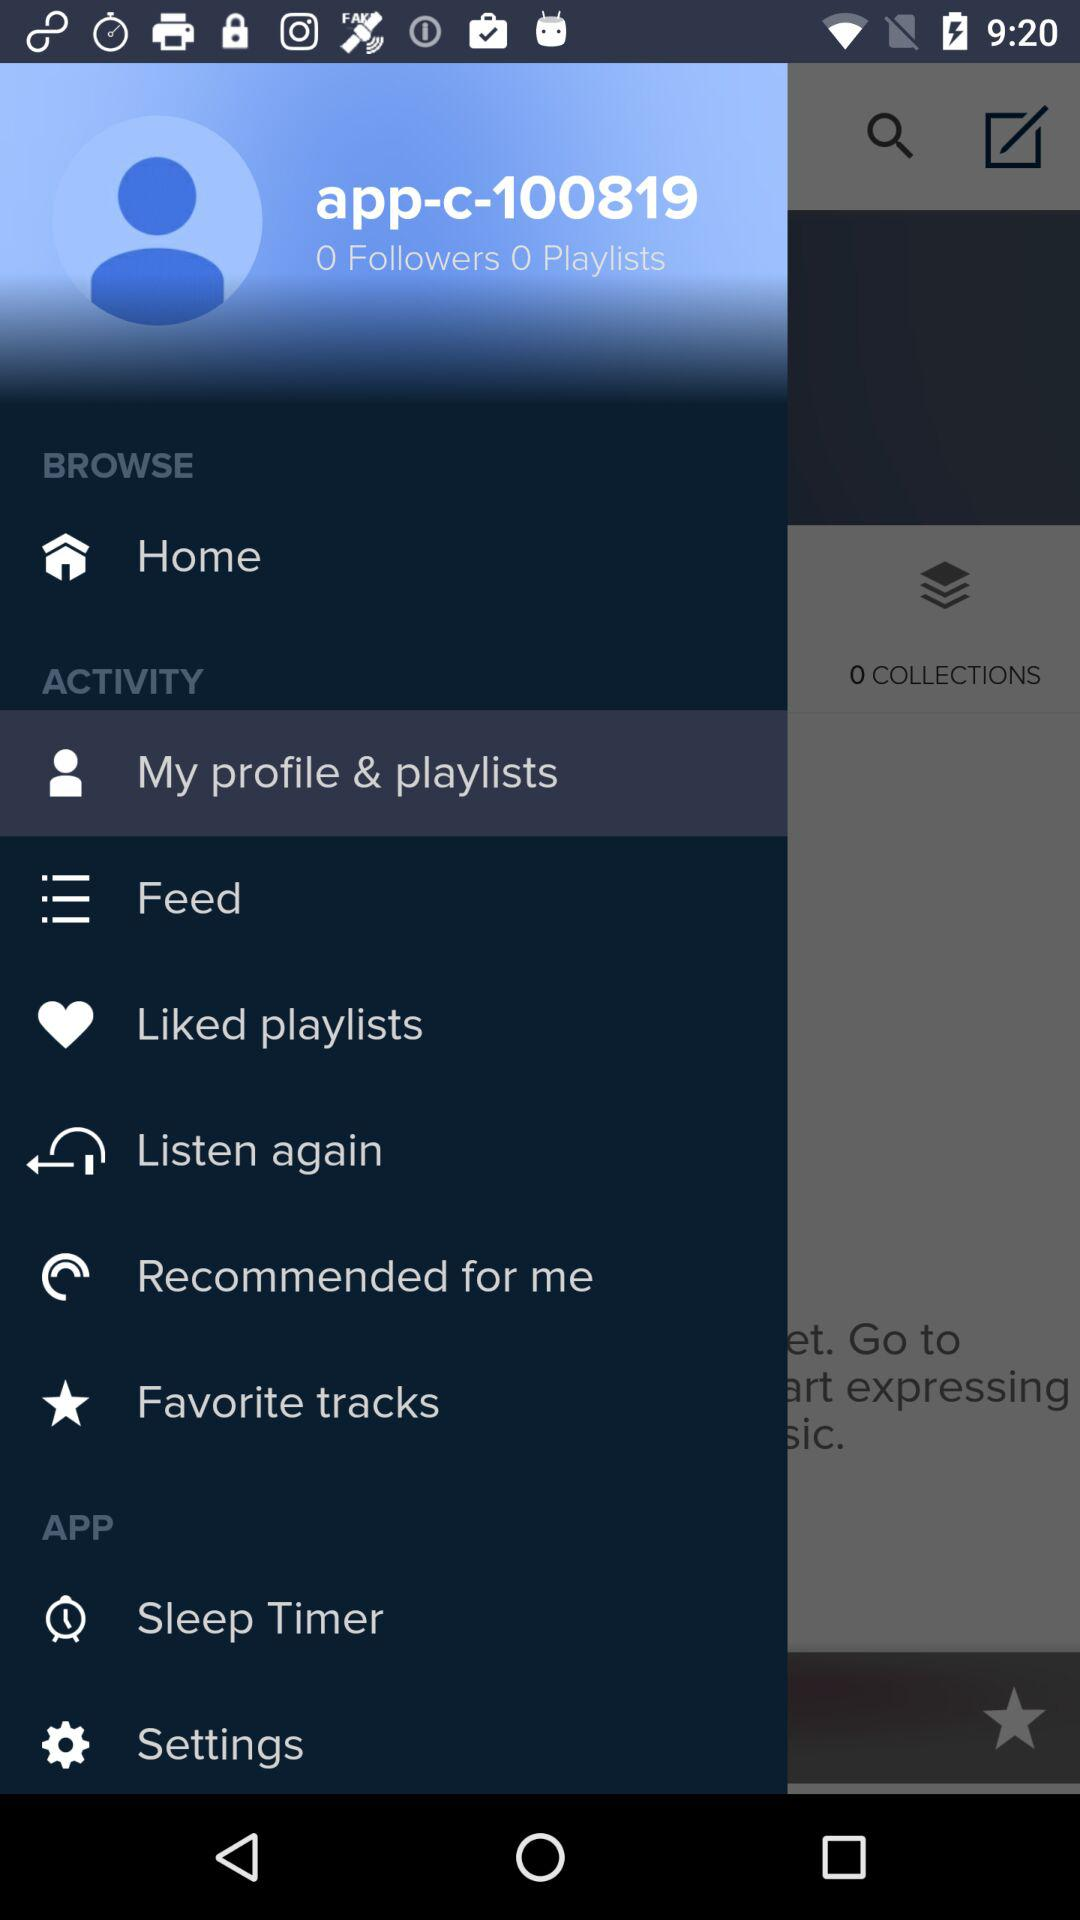What is the username? The username is "app-c-100819". 